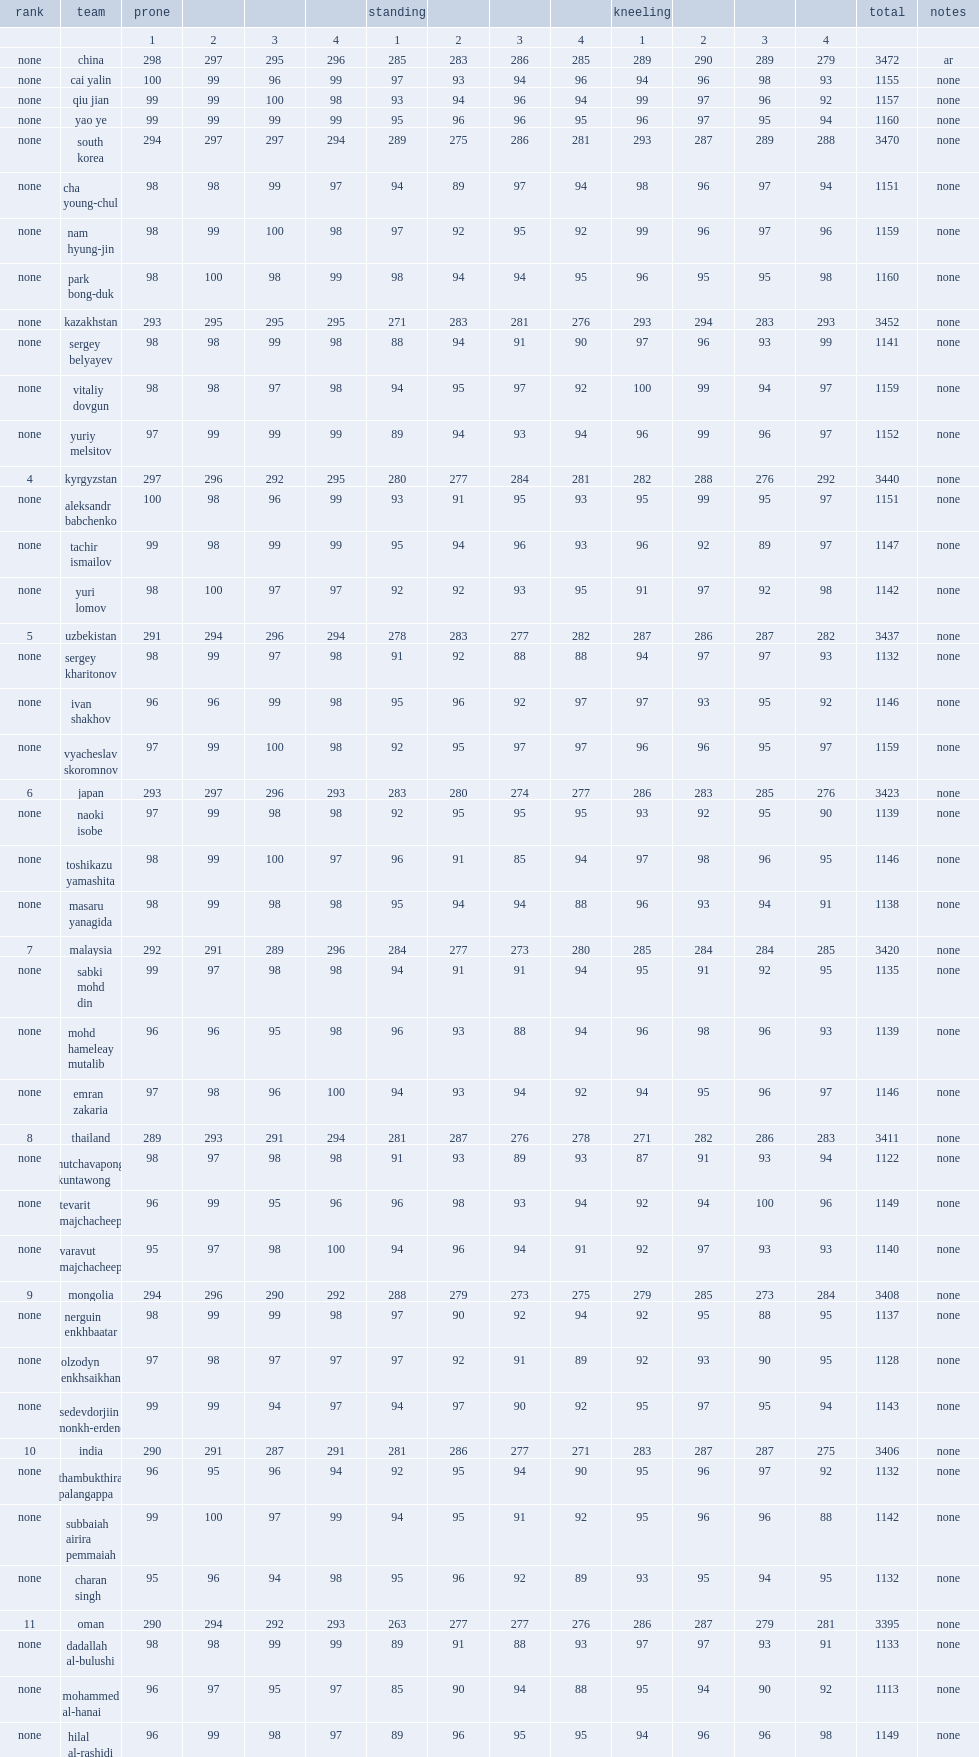How many points did the kazakhstan team score? 3452.0. 